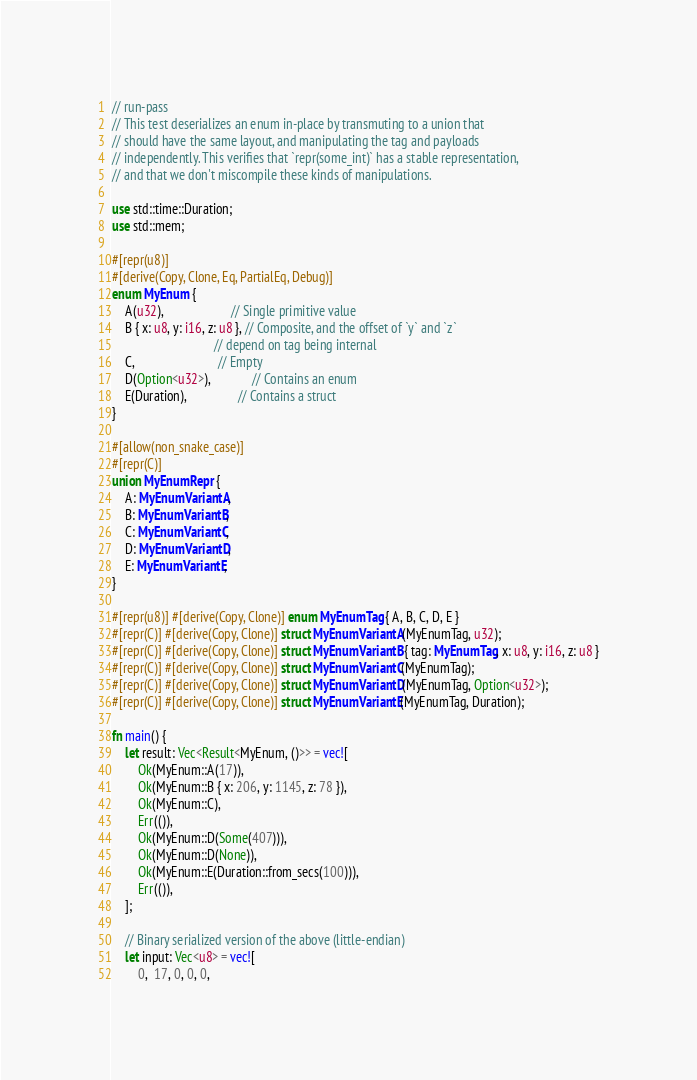<code> <loc_0><loc_0><loc_500><loc_500><_Rust_>// run-pass
// This test deserializes an enum in-place by transmuting to a union that
// should have the same layout, and manipulating the tag and payloads
// independently. This verifies that `repr(some_int)` has a stable representation,
// and that we don't miscompile these kinds of manipulations.

use std::time::Duration;
use std::mem;

#[repr(u8)]
#[derive(Copy, Clone, Eq, PartialEq, Debug)]
enum MyEnum {
    A(u32),                     // Single primitive value
    B { x: u8, y: i16, z: u8 }, // Composite, and the offset of `y` and `z`
                                // depend on tag being internal
    C,                          // Empty
    D(Option<u32>),             // Contains an enum
    E(Duration),                // Contains a struct
}

#[allow(non_snake_case)]
#[repr(C)]
union MyEnumRepr {
    A: MyEnumVariantA,
    B: MyEnumVariantB,
    C: MyEnumVariantC,
    D: MyEnumVariantD,
    E: MyEnumVariantE,
}

#[repr(u8)] #[derive(Copy, Clone)] enum MyEnumTag { A, B, C, D, E }
#[repr(C)] #[derive(Copy, Clone)] struct MyEnumVariantA(MyEnumTag, u32);
#[repr(C)] #[derive(Copy, Clone)] struct MyEnumVariantB { tag: MyEnumTag, x: u8, y: i16, z: u8 }
#[repr(C)] #[derive(Copy, Clone)] struct MyEnumVariantC(MyEnumTag);
#[repr(C)] #[derive(Copy, Clone)] struct MyEnumVariantD(MyEnumTag, Option<u32>);
#[repr(C)] #[derive(Copy, Clone)] struct MyEnumVariantE(MyEnumTag, Duration);

fn main() {
    let result: Vec<Result<MyEnum, ()>> = vec![
        Ok(MyEnum::A(17)),
        Ok(MyEnum::B { x: 206, y: 1145, z: 78 }),
        Ok(MyEnum::C),
        Err(()),
        Ok(MyEnum::D(Some(407))),
        Ok(MyEnum::D(None)),
        Ok(MyEnum::E(Duration::from_secs(100))),
        Err(()),
    ];

    // Binary serialized version of the above (little-endian)
    let input: Vec<u8> = vec![
        0,  17, 0, 0, 0,</code> 